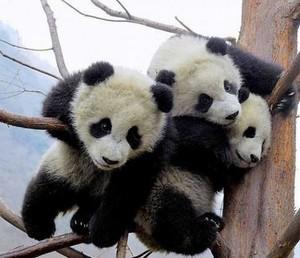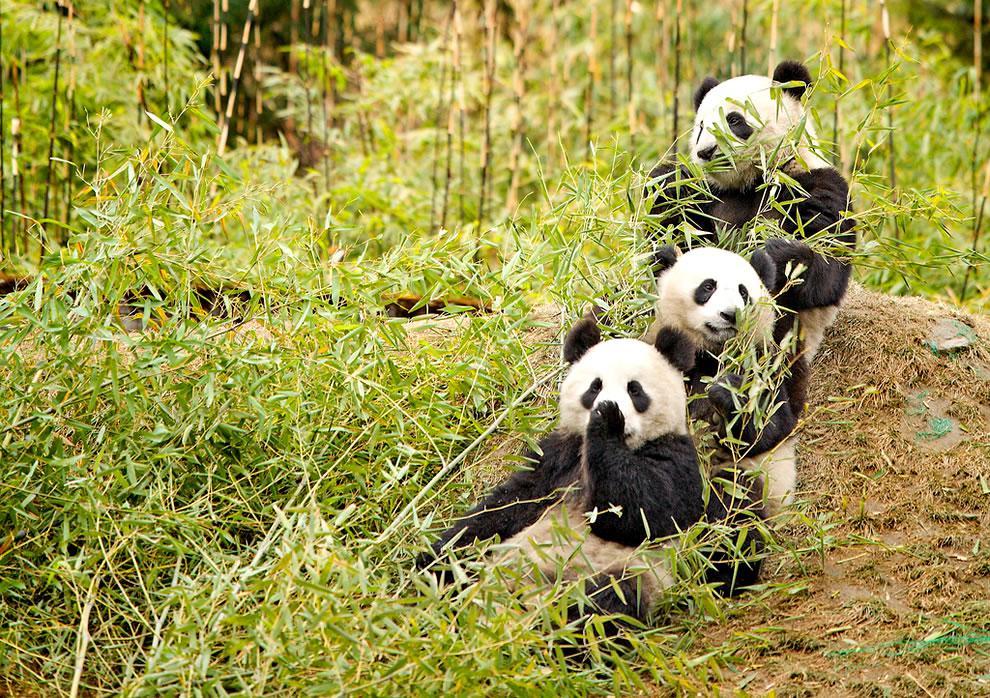The first image is the image on the left, the second image is the image on the right. Examine the images to the left and right. Is the description "Each image contains exactly three panda bears." accurate? Answer yes or no. Yes. The first image is the image on the left, the second image is the image on the right. Considering the images on both sides, is "Three pandas are grouped together on the ground in the image on the left." valid? Answer yes or no. No. 